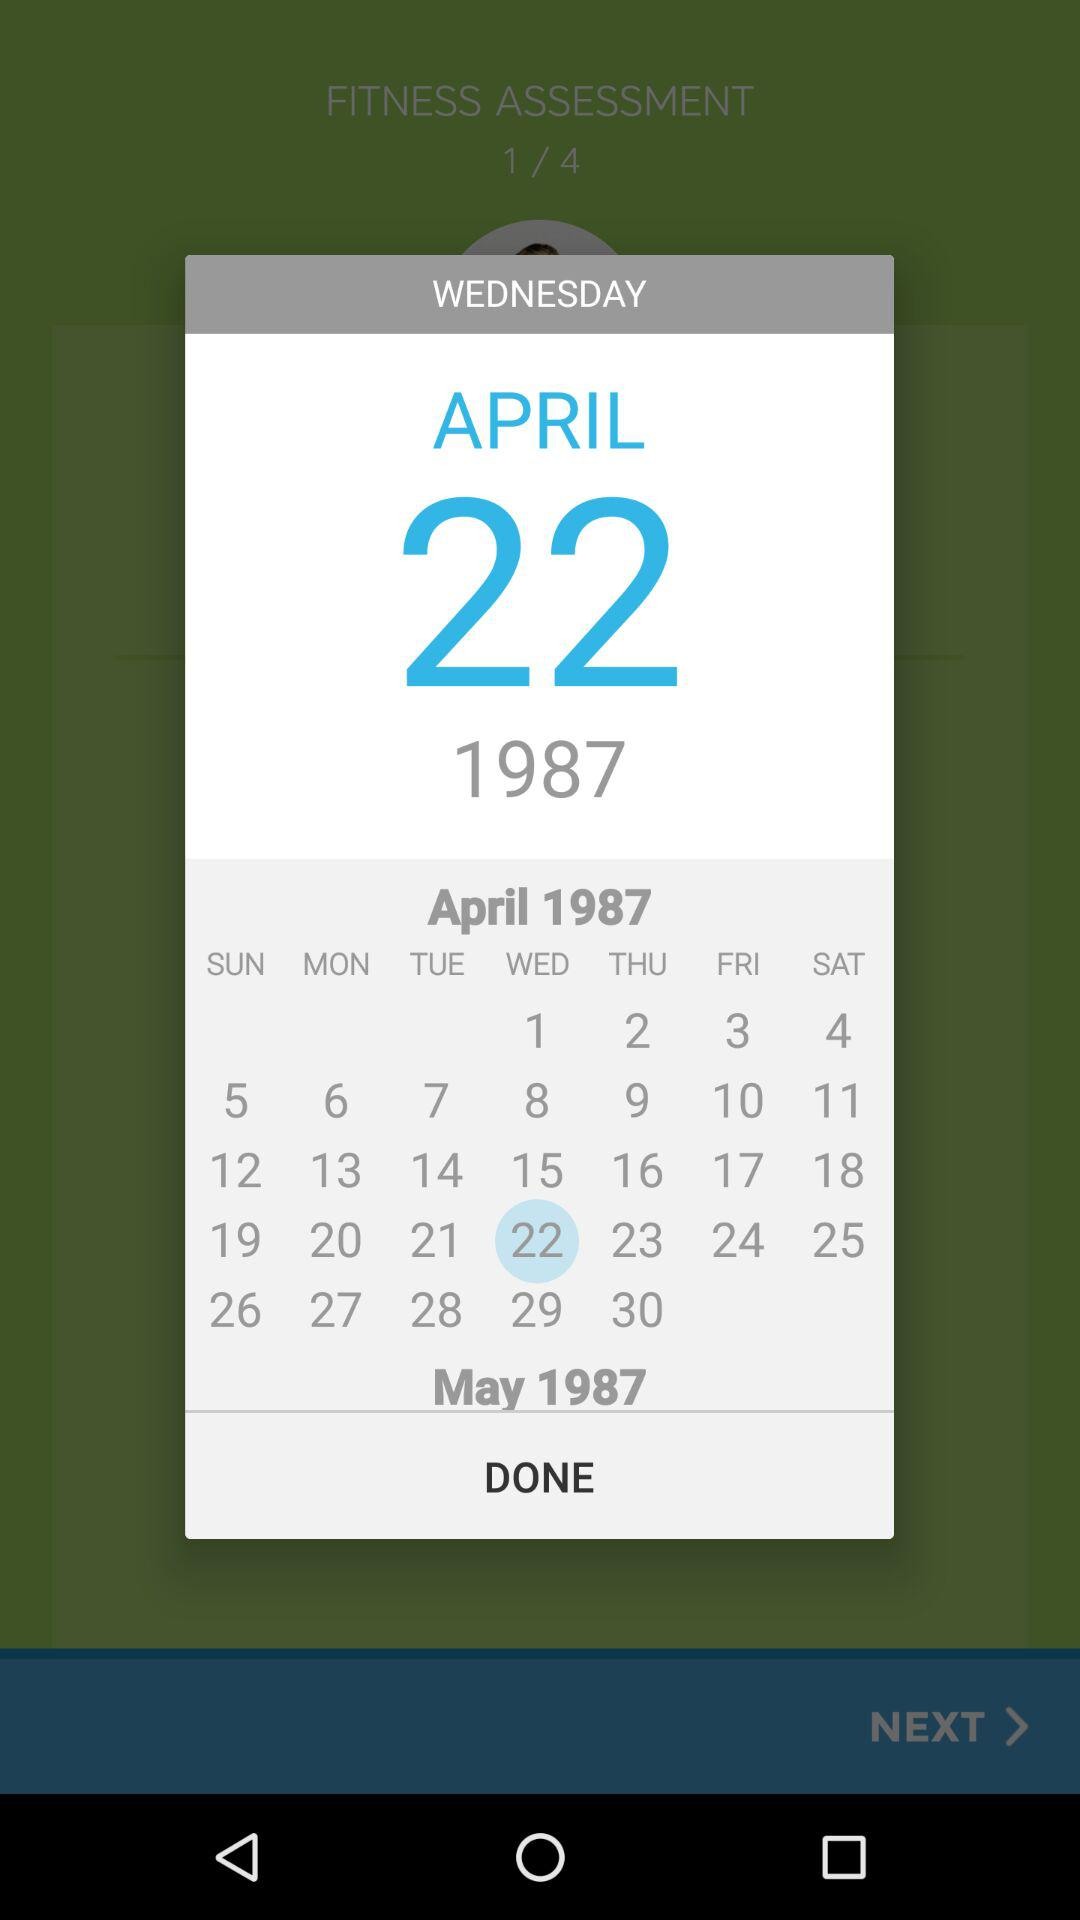Which date is selected on the calendar? The selected date is Wednesday, April 22, 1987. 